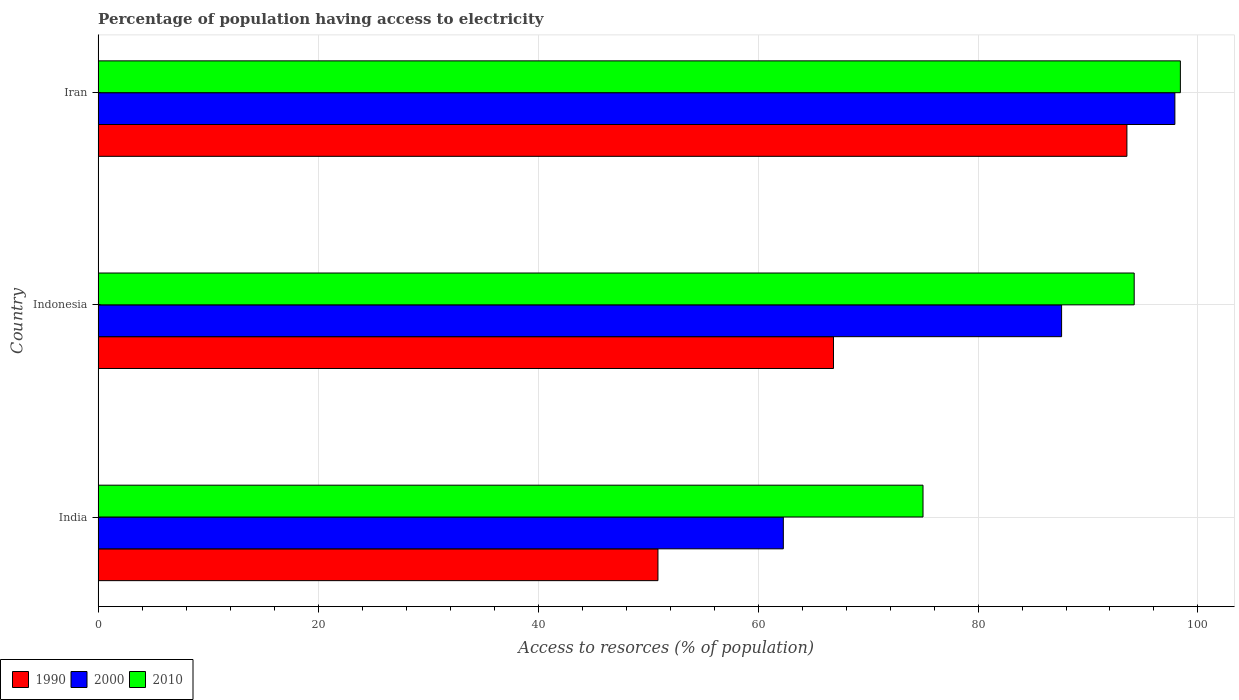Are the number of bars per tick equal to the number of legend labels?
Ensure brevity in your answer.  Yes. Are the number of bars on each tick of the Y-axis equal?
Keep it short and to the point. Yes. How many bars are there on the 2nd tick from the top?
Provide a succinct answer. 3. What is the label of the 1st group of bars from the top?
Make the answer very short. Iran. In how many cases, is the number of bars for a given country not equal to the number of legend labels?
Offer a very short reply. 0. What is the percentage of population having access to electricity in 2010 in Iran?
Offer a terse response. 98.4. Across all countries, what is the maximum percentage of population having access to electricity in 2010?
Make the answer very short. 98.4. Across all countries, what is the minimum percentage of population having access to electricity in 2010?
Keep it short and to the point. 75. In which country was the percentage of population having access to electricity in 2010 maximum?
Keep it short and to the point. Iran. In which country was the percentage of population having access to electricity in 1990 minimum?
Keep it short and to the point. India. What is the total percentage of population having access to electricity in 2000 in the graph?
Keep it short and to the point. 247.8. What is the difference between the percentage of population having access to electricity in 2010 in India and that in Iran?
Give a very brief answer. -23.4. What is the difference between the percentage of population having access to electricity in 1990 in India and the percentage of population having access to electricity in 2010 in Iran?
Provide a succinct answer. -47.5. What is the average percentage of population having access to electricity in 2010 per country?
Your response must be concise. 89.2. What is the difference between the percentage of population having access to electricity in 2000 and percentage of population having access to electricity in 1990 in India?
Your answer should be compact. 11.4. What is the ratio of the percentage of population having access to electricity in 2000 in Indonesia to that in Iran?
Provide a short and direct response. 0.89. Is the percentage of population having access to electricity in 2010 in India less than that in Iran?
Ensure brevity in your answer.  Yes. What is the difference between the highest and the second highest percentage of population having access to electricity in 2010?
Provide a succinct answer. 4.2. What is the difference between the highest and the lowest percentage of population having access to electricity in 2000?
Offer a very short reply. 35.6. Is it the case that in every country, the sum of the percentage of population having access to electricity in 2000 and percentage of population having access to electricity in 2010 is greater than the percentage of population having access to electricity in 1990?
Your answer should be very brief. Yes. How many bars are there?
Your answer should be compact. 9. How many countries are there in the graph?
Give a very brief answer. 3. What is the difference between two consecutive major ticks on the X-axis?
Make the answer very short. 20. Does the graph contain any zero values?
Make the answer very short. No. Where does the legend appear in the graph?
Give a very brief answer. Bottom left. How are the legend labels stacked?
Your response must be concise. Horizontal. What is the title of the graph?
Your response must be concise. Percentage of population having access to electricity. What is the label or title of the X-axis?
Your answer should be very brief. Access to resorces (% of population). What is the label or title of the Y-axis?
Keep it short and to the point. Country. What is the Access to resorces (% of population) in 1990 in India?
Give a very brief answer. 50.9. What is the Access to resorces (% of population) in 2000 in India?
Give a very brief answer. 62.3. What is the Access to resorces (% of population) in 2010 in India?
Your answer should be compact. 75. What is the Access to resorces (% of population) of 1990 in Indonesia?
Your response must be concise. 66.86. What is the Access to resorces (% of population) of 2000 in Indonesia?
Offer a very short reply. 87.6. What is the Access to resorces (% of population) of 2010 in Indonesia?
Provide a short and direct response. 94.2. What is the Access to resorces (% of population) in 1990 in Iran?
Keep it short and to the point. 93.54. What is the Access to resorces (% of population) of 2000 in Iran?
Offer a very short reply. 97.9. What is the Access to resorces (% of population) in 2010 in Iran?
Offer a very short reply. 98.4. Across all countries, what is the maximum Access to resorces (% of population) in 1990?
Your answer should be compact. 93.54. Across all countries, what is the maximum Access to resorces (% of population) in 2000?
Your answer should be compact. 97.9. Across all countries, what is the maximum Access to resorces (% of population) of 2010?
Your answer should be very brief. 98.4. Across all countries, what is the minimum Access to resorces (% of population) in 1990?
Provide a short and direct response. 50.9. Across all countries, what is the minimum Access to resorces (% of population) in 2000?
Keep it short and to the point. 62.3. Across all countries, what is the minimum Access to resorces (% of population) in 2010?
Provide a short and direct response. 75. What is the total Access to resorces (% of population) in 1990 in the graph?
Provide a short and direct response. 211.3. What is the total Access to resorces (% of population) in 2000 in the graph?
Offer a terse response. 247.8. What is the total Access to resorces (% of population) of 2010 in the graph?
Ensure brevity in your answer.  267.6. What is the difference between the Access to resorces (% of population) of 1990 in India and that in Indonesia?
Your answer should be very brief. -15.96. What is the difference between the Access to resorces (% of population) in 2000 in India and that in Indonesia?
Offer a very short reply. -25.3. What is the difference between the Access to resorces (% of population) of 2010 in India and that in Indonesia?
Make the answer very short. -19.2. What is the difference between the Access to resorces (% of population) of 1990 in India and that in Iran?
Ensure brevity in your answer.  -42.64. What is the difference between the Access to resorces (% of population) in 2000 in India and that in Iran?
Your answer should be very brief. -35.6. What is the difference between the Access to resorces (% of population) in 2010 in India and that in Iran?
Provide a short and direct response. -23.4. What is the difference between the Access to resorces (% of population) in 1990 in Indonesia and that in Iran?
Give a very brief answer. -26.68. What is the difference between the Access to resorces (% of population) in 2000 in Indonesia and that in Iran?
Provide a succinct answer. -10.3. What is the difference between the Access to resorces (% of population) of 2010 in Indonesia and that in Iran?
Your response must be concise. -4.2. What is the difference between the Access to resorces (% of population) in 1990 in India and the Access to resorces (% of population) in 2000 in Indonesia?
Offer a very short reply. -36.7. What is the difference between the Access to resorces (% of population) of 1990 in India and the Access to resorces (% of population) of 2010 in Indonesia?
Provide a short and direct response. -43.3. What is the difference between the Access to resorces (% of population) of 2000 in India and the Access to resorces (% of population) of 2010 in Indonesia?
Your answer should be compact. -31.9. What is the difference between the Access to resorces (% of population) in 1990 in India and the Access to resorces (% of population) in 2000 in Iran?
Provide a short and direct response. -47. What is the difference between the Access to resorces (% of population) of 1990 in India and the Access to resorces (% of population) of 2010 in Iran?
Offer a very short reply. -47.5. What is the difference between the Access to resorces (% of population) of 2000 in India and the Access to resorces (% of population) of 2010 in Iran?
Offer a very short reply. -36.1. What is the difference between the Access to resorces (% of population) in 1990 in Indonesia and the Access to resorces (% of population) in 2000 in Iran?
Give a very brief answer. -31.04. What is the difference between the Access to resorces (% of population) of 1990 in Indonesia and the Access to resorces (% of population) of 2010 in Iran?
Your answer should be compact. -31.54. What is the average Access to resorces (% of population) of 1990 per country?
Your response must be concise. 70.43. What is the average Access to resorces (% of population) of 2000 per country?
Your answer should be very brief. 82.6. What is the average Access to resorces (% of population) of 2010 per country?
Provide a short and direct response. 89.2. What is the difference between the Access to resorces (% of population) in 1990 and Access to resorces (% of population) in 2010 in India?
Provide a short and direct response. -24.1. What is the difference between the Access to resorces (% of population) in 1990 and Access to resorces (% of population) in 2000 in Indonesia?
Ensure brevity in your answer.  -20.74. What is the difference between the Access to resorces (% of population) of 1990 and Access to resorces (% of population) of 2010 in Indonesia?
Offer a terse response. -27.34. What is the difference between the Access to resorces (% of population) in 2000 and Access to resorces (% of population) in 2010 in Indonesia?
Keep it short and to the point. -6.6. What is the difference between the Access to resorces (% of population) of 1990 and Access to resorces (% of population) of 2000 in Iran?
Your response must be concise. -4.36. What is the difference between the Access to resorces (% of population) of 1990 and Access to resorces (% of population) of 2010 in Iran?
Ensure brevity in your answer.  -4.86. What is the ratio of the Access to resorces (% of population) of 1990 in India to that in Indonesia?
Your answer should be compact. 0.76. What is the ratio of the Access to resorces (% of population) of 2000 in India to that in Indonesia?
Give a very brief answer. 0.71. What is the ratio of the Access to resorces (% of population) in 2010 in India to that in Indonesia?
Keep it short and to the point. 0.8. What is the ratio of the Access to resorces (% of population) in 1990 in India to that in Iran?
Offer a terse response. 0.54. What is the ratio of the Access to resorces (% of population) in 2000 in India to that in Iran?
Ensure brevity in your answer.  0.64. What is the ratio of the Access to resorces (% of population) in 2010 in India to that in Iran?
Your answer should be very brief. 0.76. What is the ratio of the Access to resorces (% of population) in 1990 in Indonesia to that in Iran?
Your answer should be very brief. 0.71. What is the ratio of the Access to resorces (% of population) of 2000 in Indonesia to that in Iran?
Make the answer very short. 0.89. What is the ratio of the Access to resorces (% of population) of 2010 in Indonesia to that in Iran?
Give a very brief answer. 0.96. What is the difference between the highest and the second highest Access to resorces (% of population) in 1990?
Your answer should be compact. 26.68. What is the difference between the highest and the second highest Access to resorces (% of population) of 2000?
Offer a very short reply. 10.3. What is the difference between the highest and the second highest Access to resorces (% of population) in 2010?
Make the answer very short. 4.2. What is the difference between the highest and the lowest Access to resorces (% of population) of 1990?
Offer a very short reply. 42.64. What is the difference between the highest and the lowest Access to resorces (% of population) of 2000?
Your answer should be compact. 35.6. What is the difference between the highest and the lowest Access to resorces (% of population) in 2010?
Provide a succinct answer. 23.4. 